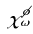Convert formula to latex. <formula><loc_0><loc_0><loc_500><loc_500>\chi _ { \omega } ^ { \phi }</formula> 